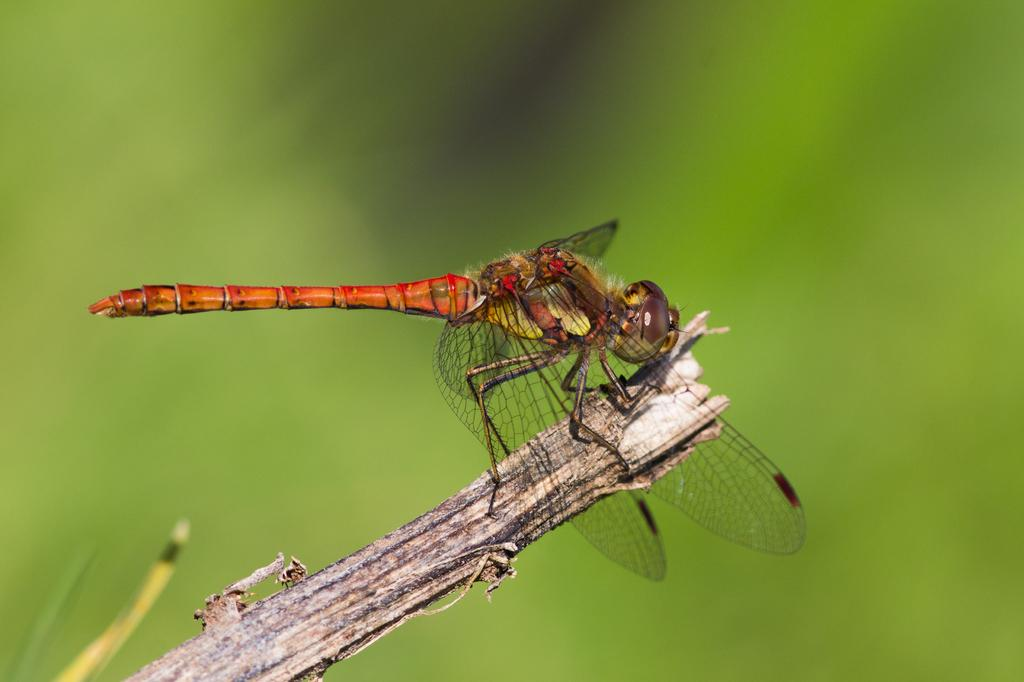What object can be seen in the image? There is a stick in the image. What is on the stick? A dragonfly is on the stick. What can be observed about the background of the image? The background of the image has a green color. What type of shoe is the dragonfly wearing on the stick? There is no shoe present in the image, as the dragonfly is on a stick and not wearing any footwear. 